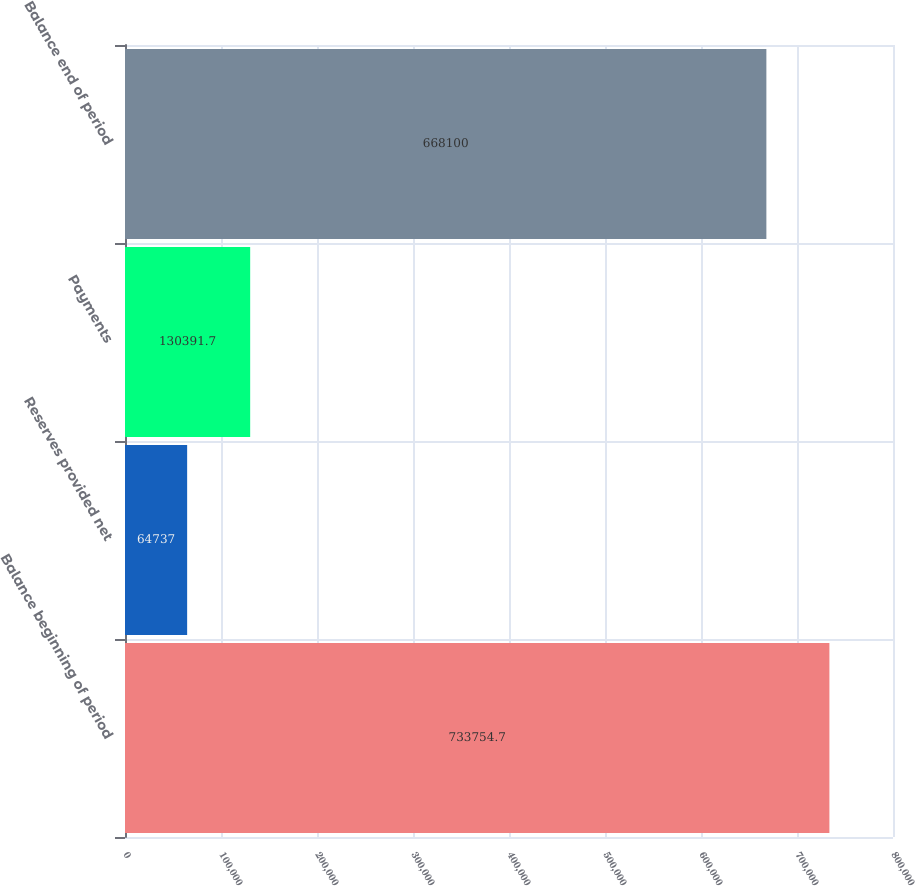Convert chart to OTSL. <chart><loc_0><loc_0><loc_500><loc_500><bar_chart><fcel>Balance beginning of period<fcel>Reserves provided net<fcel>Payments<fcel>Balance end of period<nl><fcel>733755<fcel>64737<fcel>130392<fcel>668100<nl></chart> 